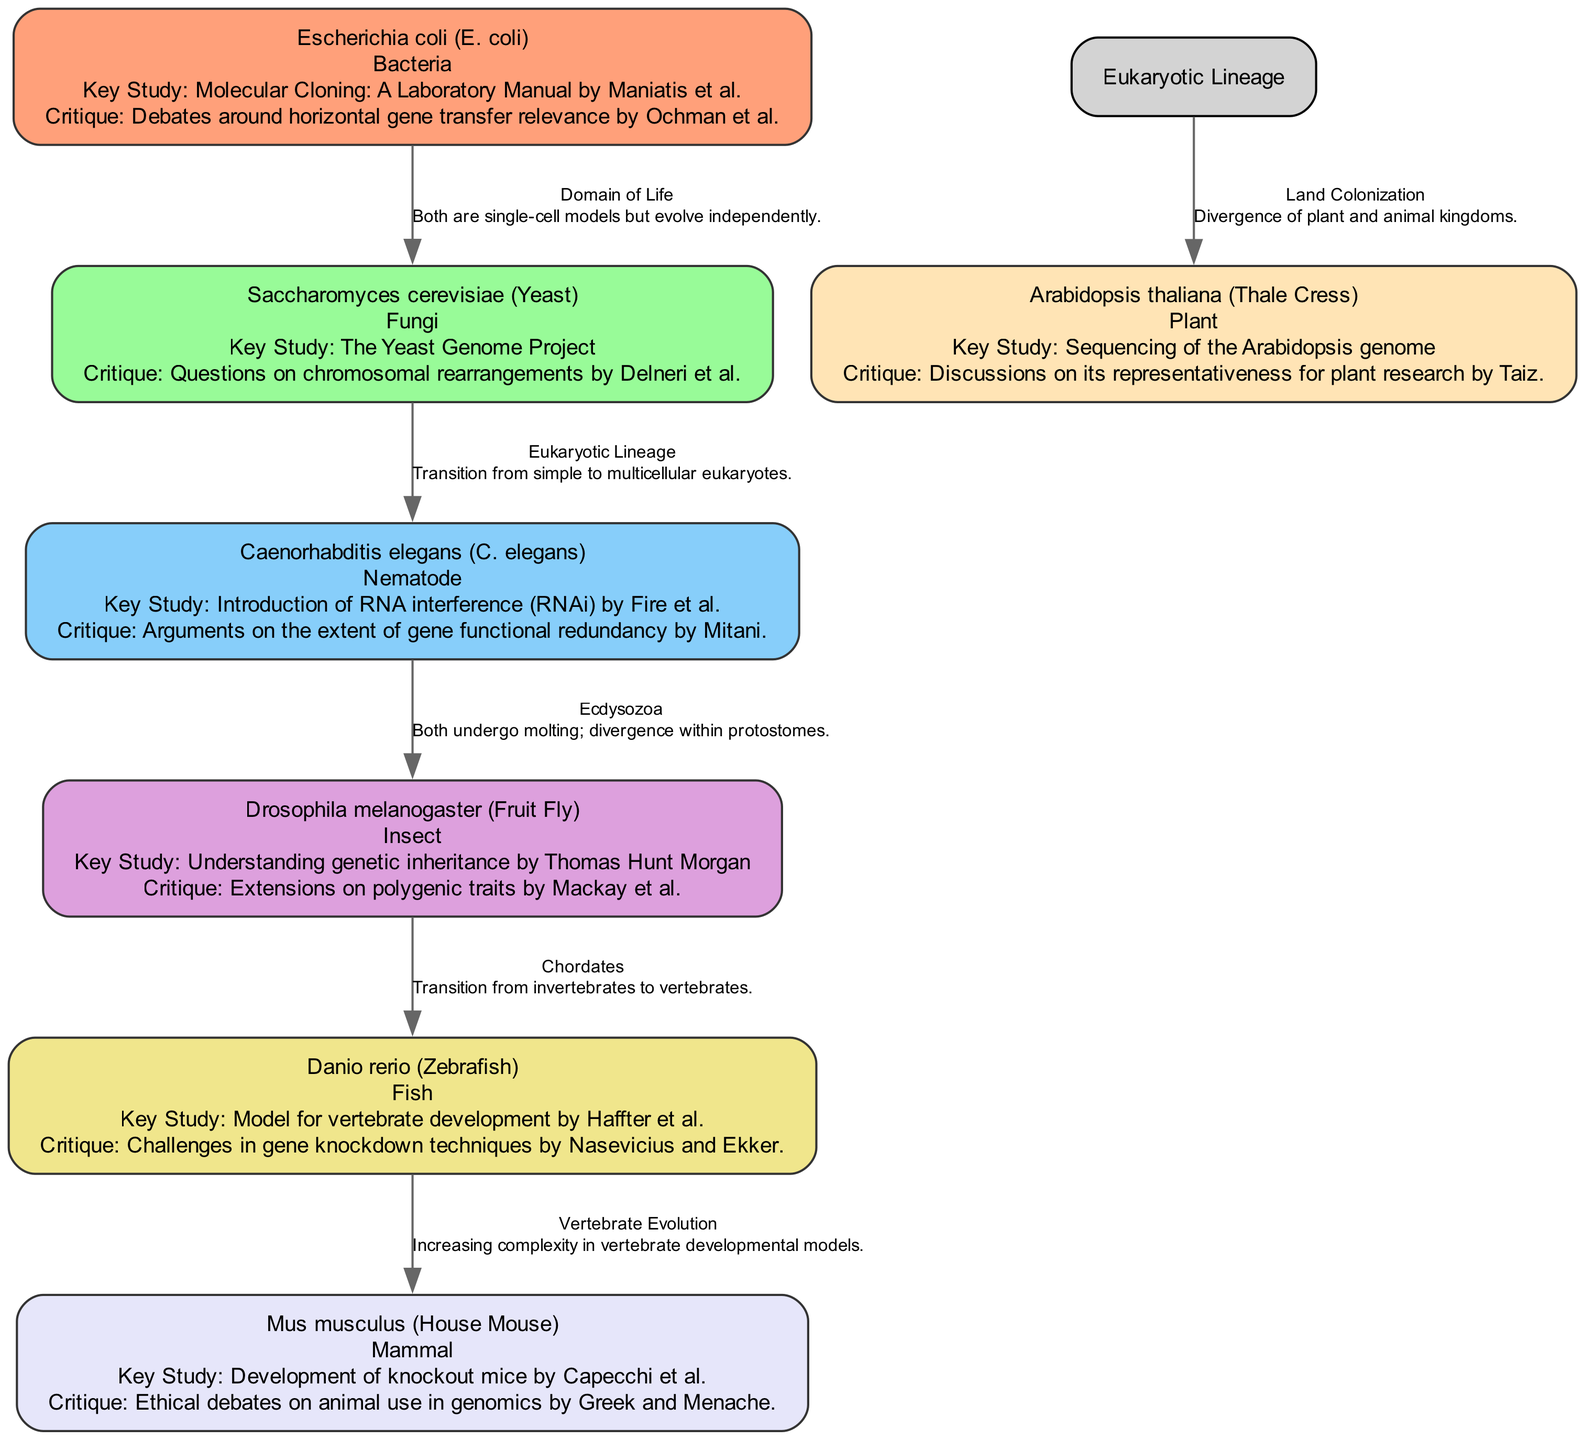What is the role of Escherichia coli in this diagram? The role of Escherichia coli is specified as "Bacteria." This information can be found in the node for E. coli within the diagram, which details its classification in the context of model organisms.
Answer: Bacteria Which study is key for Drosophila melanogaster? The key study associated with Drosophila melanogaster is "Understanding genetic inheritance by Thomas Hunt Morgan." This is directly mentioned in the corresponding node for Drosophila in the diagram.
Answer: Understanding genetic inheritance by Thomas Hunt Morgan How many model organisms are represented in total? The total number of model organisms can be counted directly from the nodes present in the diagram. There are seven distinct model organisms listed on the diagram.
Answer: Seven What type of evolutionary relationship exists between Fungi and Nematode? The type of evolutionary relationship between Fungi and Nematode is defined as "Eukaryotic Lineage." This can be found by examining the connecting edge between the Fungi and Nematode nodes, which describes their relationship type.
Answer: Eukaryotic Lineage Which model organism is linked with ethical debates about animal use? The model organism linked with ethical debates about animal use is "Mus musculus." This can be deduced from the node information about Mus musculus that explicitly states the critique related to ethical debates.
Answer: Mus musculus What is the key critique regarding Saccharomyces cerevisiae? The key critique regarding Saccharomyces cerevisiae is "Questions on chromosomal rearrangements by Delneri et al." This critique is provided in the node for Saccharomyces cerevisiae, indicating the challenges faced in its studies.
Answer: Questions on chromosomal rearrangements by Delneri et al How do Nematodes relate to Insects according to the diagram? Nematodes relate to Insects through the evolutionary category "Ecdysozoa." This can be found by following the edge connecting the two categories, where the relationship type is articulated.
Answer: Ecdysozoa What is the nature of the relationship between Fish and Mammals? The nature of the relationship between Fish and Mammals is classified as "Vertebrate Evolution." This information is shown on the edge connecting Fish and Mammals in the diagram.
Answer: Vertebrate Evolution What does the relationship note between Bacteria and Fungi state? The relationship note between Bacteria and Fungi states that "Both are single-cell models but evolve independently." This note provides insight into their evolutionary context as outlined by the edge connecting these two domains.
Answer: Both are single-cell models but evolve independently 